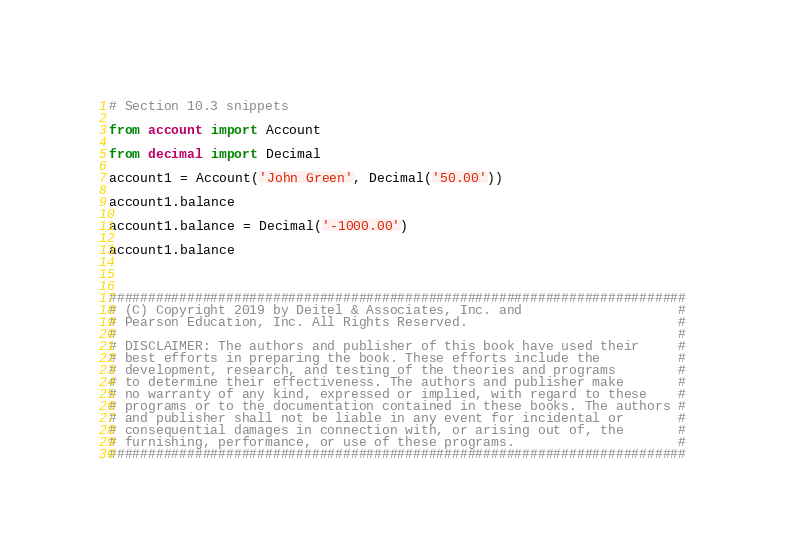<code> <loc_0><loc_0><loc_500><loc_500><_Python_># Section 10.3 snippets

from account import Account

from decimal import Decimal

account1 = Account('John Green', Decimal('50.00'))

account1.balance

account1.balance = Decimal('-1000.00')

account1.balance



##########################################################################
# (C) Copyright 2019 by Deitel & Associates, Inc. and                    #
# Pearson Education, Inc. All Rights Reserved.                           #
#                                                                        #
# DISCLAIMER: The authors and publisher of this book have used their     #
# best efforts in preparing the book. These efforts include the          #
# development, research, and testing of the theories and programs        #
# to determine their effectiveness. The authors and publisher make       #
# no warranty of any kind, expressed or implied, with regard to these    #
# programs or to the documentation contained in these books. The authors #
# and publisher shall not be liable in any event for incidental or       #
# consequential damages in connection with, or arising out of, the       #
# furnishing, performance, or use of these programs.                     #
##########################################################################
</code> 